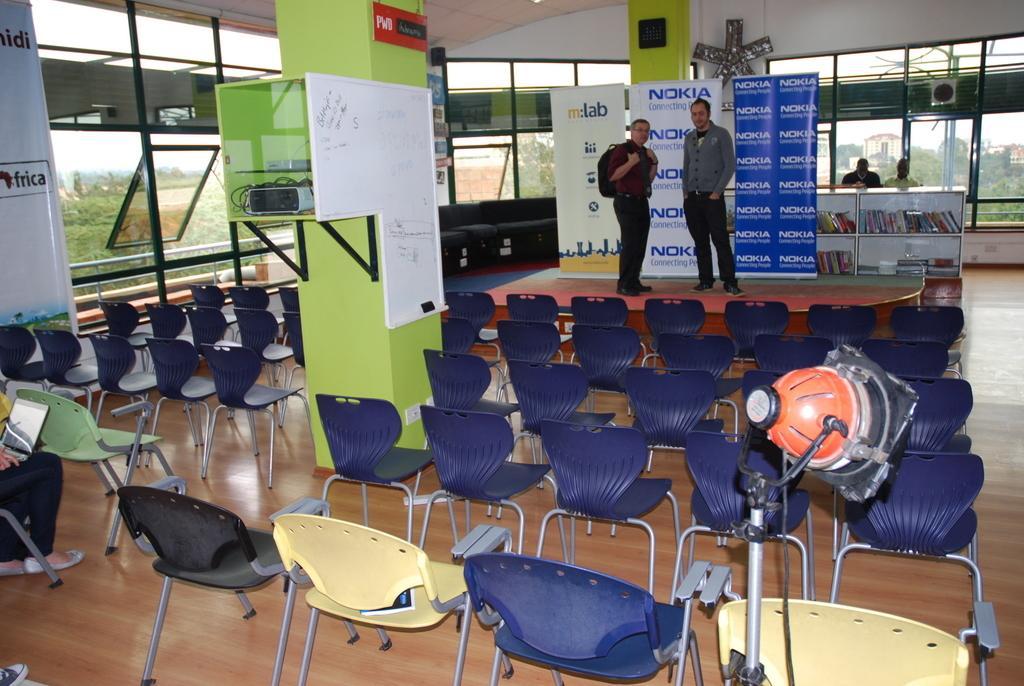How would you summarize this image in a sentence or two? In this picture there are two persons standing. At the back there are two persons behind the cupboard and there are books inside the cupboard. In the foreground there are chairs and there is a light and there is a person sitting on the chair and holding the laptop. There are devices in the cupboard and there is a board on the wall. At the back there are hoardings. Behind the windows there are trees and buildings. At the top there is sky. 